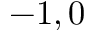Convert formula to latex. <formula><loc_0><loc_0><loc_500><loc_500>- 1 , 0</formula> 